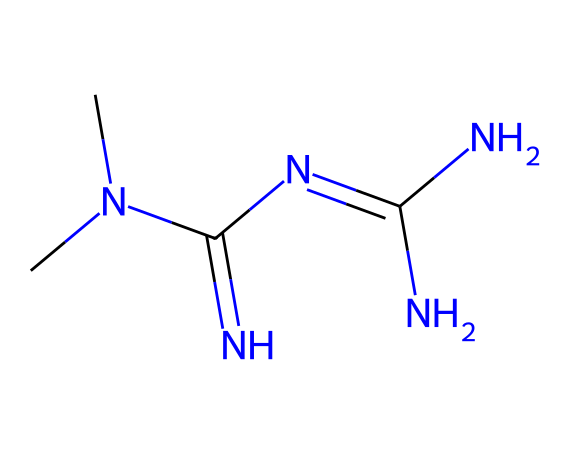What is the total number of nitrogen atoms in Metformin? By examining the SMILES representation, we can identify that there are five nitrogen (N) atoms present in the structure.
Answer: five How many carbon atoms are present in Metformin? The SMILES representation indicates the presence of three carbon (C) atoms in the structure of Metformin.
Answer: three What is the functional group primarily present in Metformin? The presence of the carbon-nitrogen double bond (C=N) suggests that the primary functional group in Metformin is an amidine.
Answer: amidine How many total hydrogen atoms are attached to the carbon atoms in Metformin? Each carbon atom in the structure contributes a specific number of hydrogen atoms based on its bonding; therefore, there are a total of seven hydrogen (H) atoms in the chemical.
Answer: seven Which atoms in Metformin indicate its role as an antidiabetic agent? The arrangement of nitrogen atoms and the amidine functional group in the structure reflects the drug's ability to regulate glucose levels, classifying it as an antidiabetic agent.
Answer: nitrogen atoms What type of bonds connect the nitrogen atoms in Metformin? The SMILES representation reveals that the nitrogen atoms are largely connected through single bonds, with one notable double bond (C=N), showing the nature of their connections.
Answer: single and one double bond 